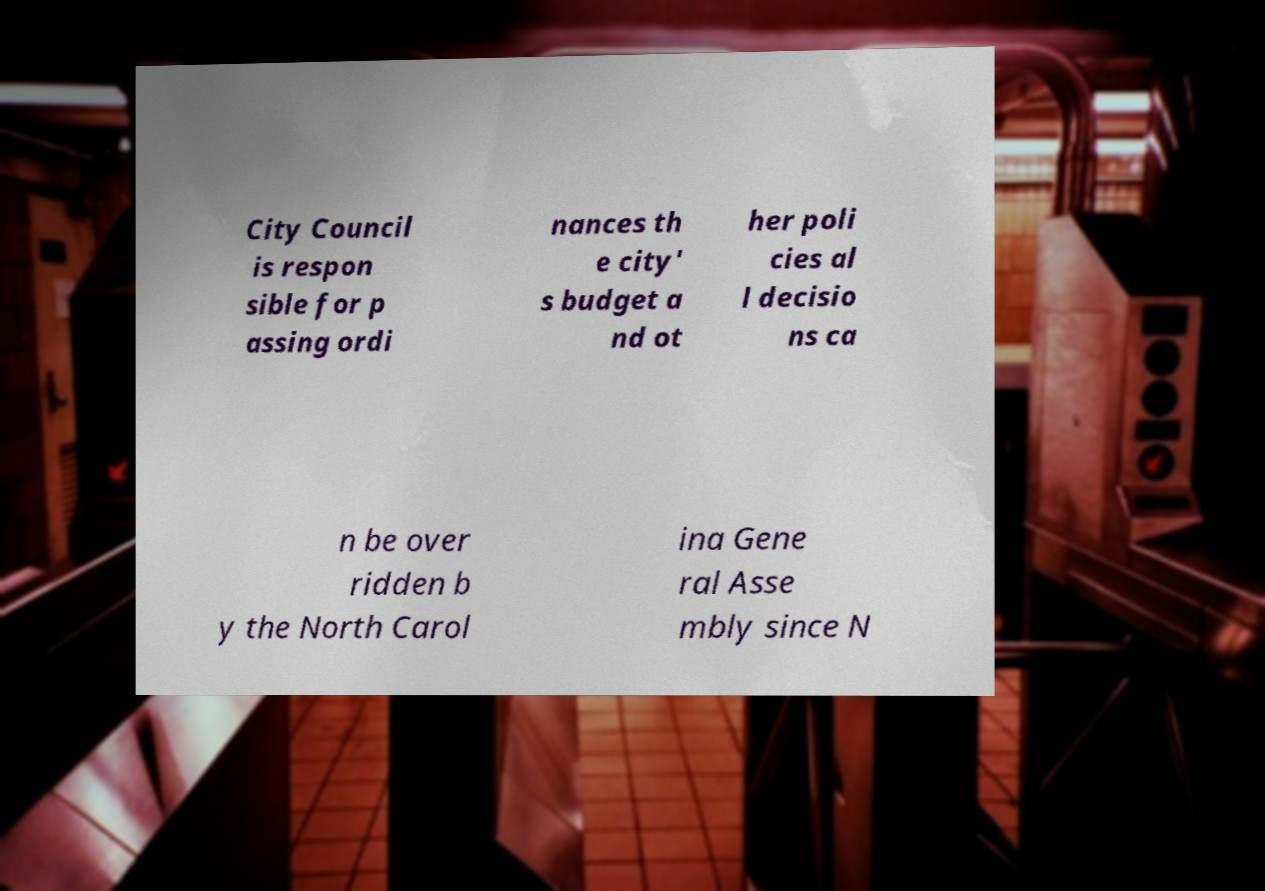What messages or text are displayed in this image? I need them in a readable, typed format. City Council is respon sible for p assing ordi nances th e city' s budget a nd ot her poli cies al l decisio ns ca n be over ridden b y the North Carol ina Gene ral Asse mbly since N 